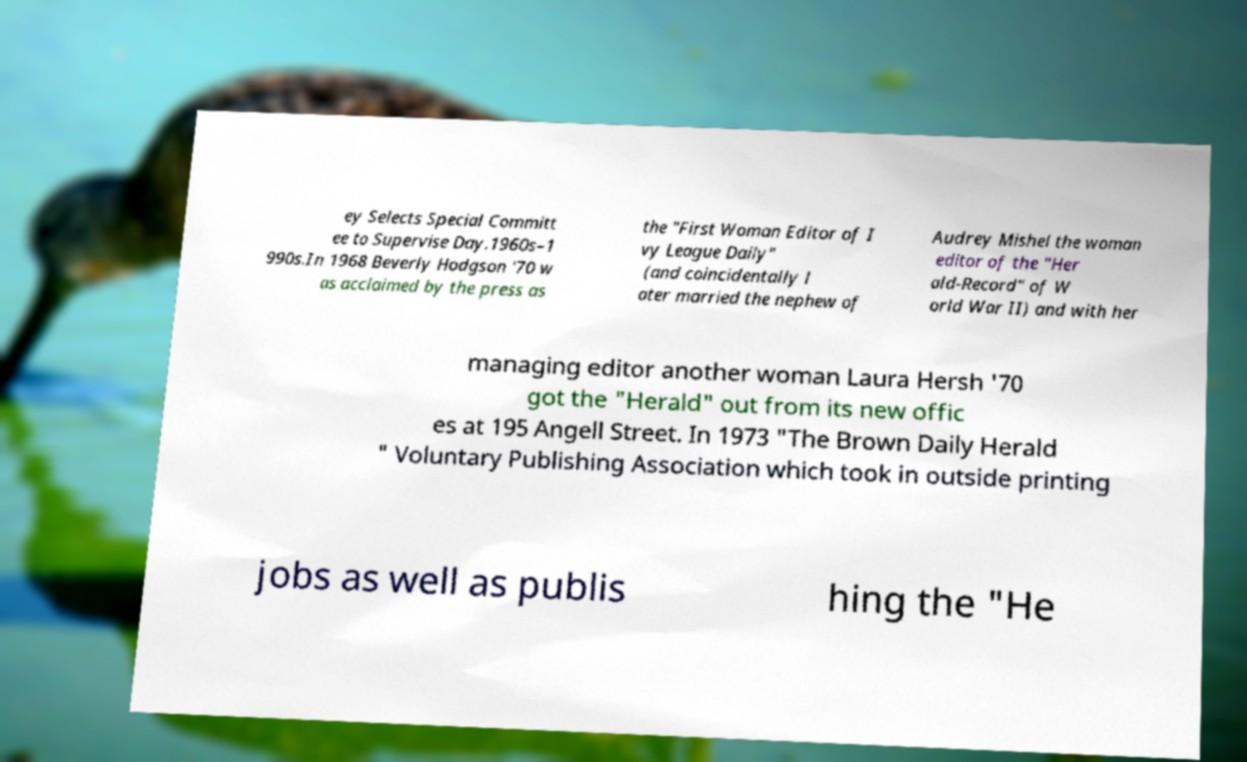Can you read and provide the text displayed in the image?This photo seems to have some interesting text. Can you extract and type it out for me? ey Selects Special Committ ee to Supervise Day.1960s–1 990s.In 1968 Beverly Hodgson '70 w as acclaimed by the press as the "First Woman Editor of I vy League Daily" (and coincidentally l ater married the nephew of Audrey Mishel the woman editor of the "Her ald-Record" of W orld War II) and with her managing editor another woman Laura Hersh '70 got the "Herald" out from its new offic es at 195 Angell Street. In 1973 "The Brown Daily Herald " Voluntary Publishing Association which took in outside printing jobs as well as publis hing the "He 